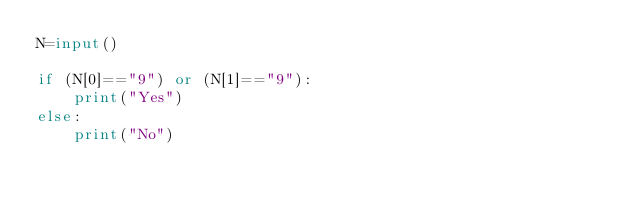<code> <loc_0><loc_0><loc_500><loc_500><_Python_>N=input()

if (N[0]=="9") or (N[1]=="9"):
	print("Yes")
else:
	print("No")</code> 